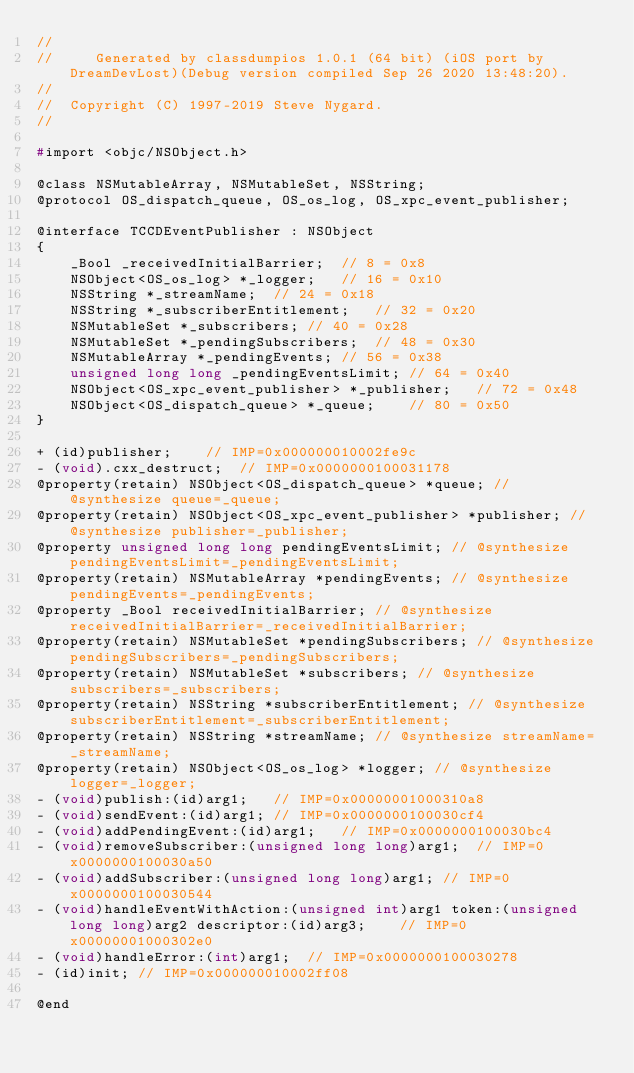Convert code to text. <code><loc_0><loc_0><loc_500><loc_500><_C_>//
//     Generated by classdumpios 1.0.1 (64 bit) (iOS port by DreamDevLost)(Debug version compiled Sep 26 2020 13:48:20).
//
//  Copyright (C) 1997-2019 Steve Nygard.
//

#import <objc/NSObject.h>

@class NSMutableArray, NSMutableSet, NSString;
@protocol OS_dispatch_queue, OS_os_log, OS_xpc_event_publisher;

@interface TCCDEventPublisher : NSObject
{
    _Bool _receivedInitialBarrier;	// 8 = 0x8
    NSObject<OS_os_log> *_logger;	// 16 = 0x10
    NSString *_streamName;	// 24 = 0x18
    NSString *_subscriberEntitlement;	// 32 = 0x20
    NSMutableSet *_subscribers;	// 40 = 0x28
    NSMutableSet *_pendingSubscribers;	// 48 = 0x30
    NSMutableArray *_pendingEvents;	// 56 = 0x38
    unsigned long long _pendingEventsLimit;	// 64 = 0x40
    NSObject<OS_xpc_event_publisher> *_publisher;	// 72 = 0x48
    NSObject<OS_dispatch_queue> *_queue;	// 80 = 0x50
}

+ (id)publisher;	// IMP=0x000000010002fe9c
- (void).cxx_destruct;	// IMP=0x0000000100031178
@property(retain) NSObject<OS_dispatch_queue> *queue; // @synthesize queue=_queue;
@property(retain) NSObject<OS_xpc_event_publisher> *publisher; // @synthesize publisher=_publisher;
@property unsigned long long pendingEventsLimit; // @synthesize pendingEventsLimit=_pendingEventsLimit;
@property(retain) NSMutableArray *pendingEvents; // @synthesize pendingEvents=_pendingEvents;
@property _Bool receivedInitialBarrier; // @synthesize receivedInitialBarrier=_receivedInitialBarrier;
@property(retain) NSMutableSet *pendingSubscribers; // @synthesize pendingSubscribers=_pendingSubscribers;
@property(retain) NSMutableSet *subscribers; // @synthesize subscribers=_subscribers;
@property(retain) NSString *subscriberEntitlement; // @synthesize subscriberEntitlement=_subscriberEntitlement;
@property(retain) NSString *streamName; // @synthesize streamName=_streamName;
@property(retain) NSObject<OS_os_log> *logger; // @synthesize logger=_logger;
- (void)publish:(id)arg1;	// IMP=0x00000001000310a8
- (void)sendEvent:(id)arg1;	// IMP=0x0000000100030cf4
- (void)addPendingEvent:(id)arg1;	// IMP=0x0000000100030bc4
- (void)removeSubscriber:(unsigned long long)arg1;	// IMP=0x0000000100030a50
- (void)addSubscriber:(unsigned long long)arg1;	// IMP=0x0000000100030544
- (void)handleEventWithAction:(unsigned int)arg1 token:(unsigned long long)arg2 descriptor:(id)arg3;	// IMP=0x00000001000302e0
- (void)handleError:(int)arg1;	// IMP=0x0000000100030278
- (id)init;	// IMP=0x000000010002ff08

@end

</code> 